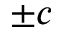Convert formula to latex. <formula><loc_0><loc_0><loc_500><loc_500>\pm c</formula> 